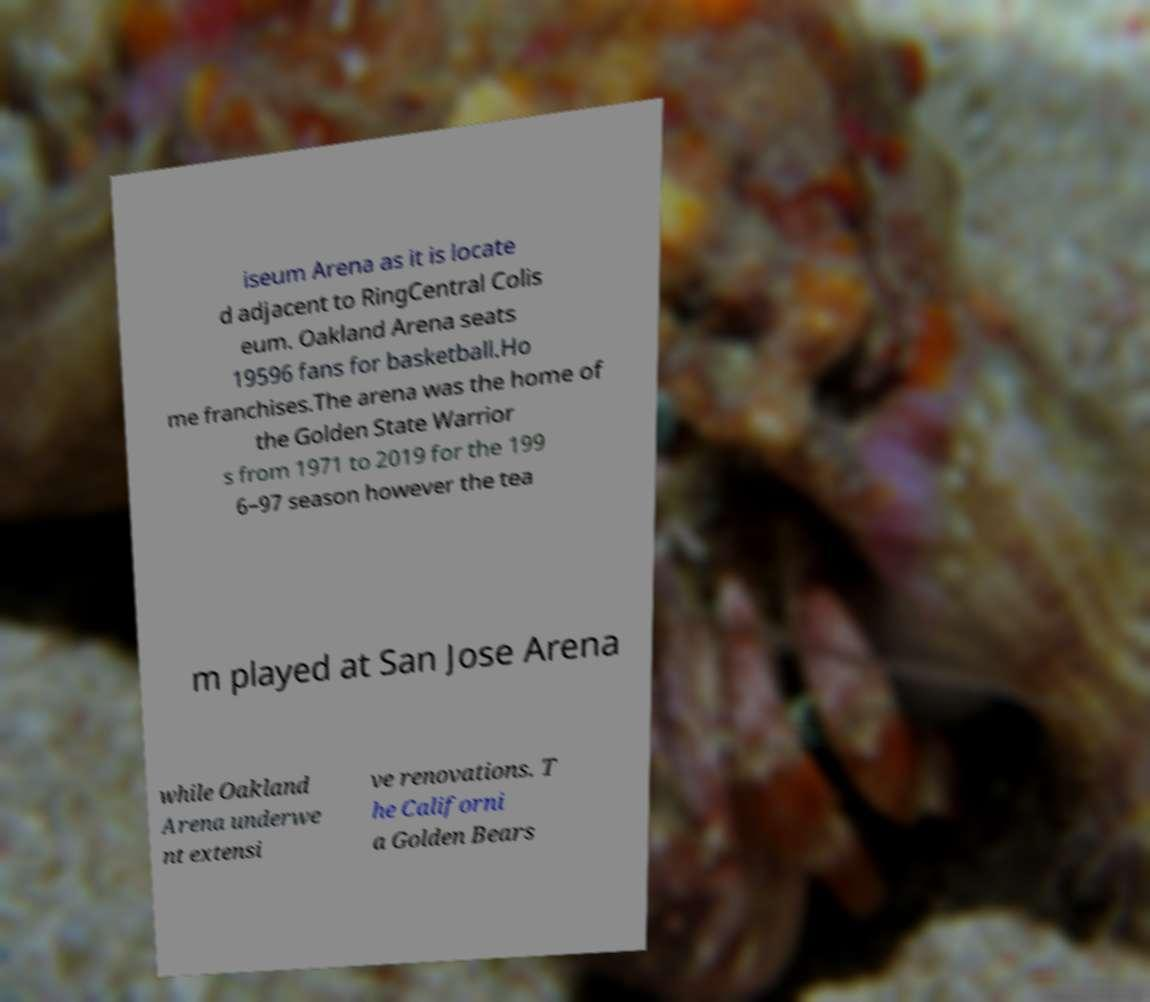Can you read and provide the text displayed in the image?This photo seems to have some interesting text. Can you extract and type it out for me? iseum Arena as it is locate d adjacent to RingCentral Colis eum. Oakland Arena seats 19596 fans for basketball.Ho me franchises.The arena was the home of the Golden State Warrior s from 1971 to 2019 for the 199 6–97 season however the tea m played at San Jose Arena while Oakland Arena underwe nt extensi ve renovations. T he Californi a Golden Bears 